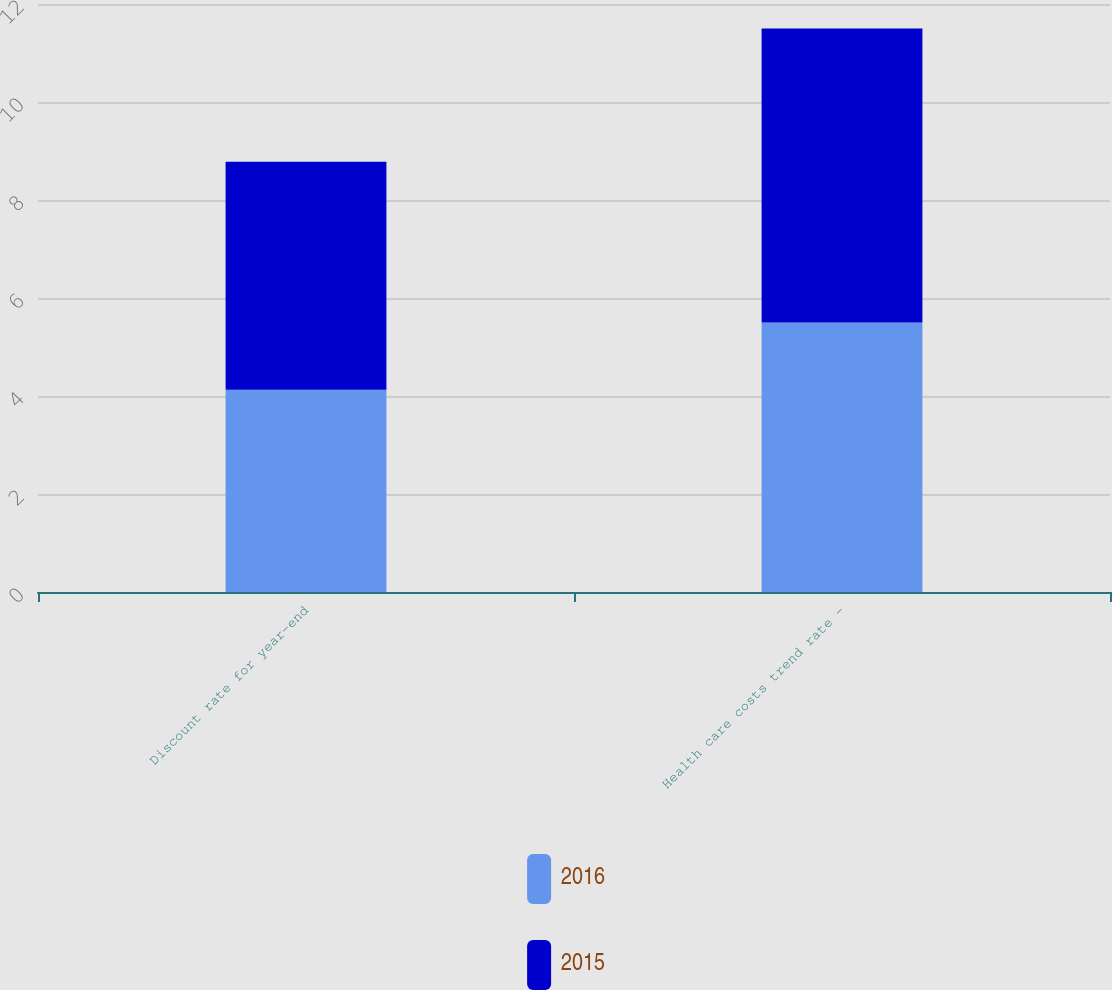Convert chart to OTSL. <chart><loc_0><loc_0><loc_500><loc_500><stacked_bar_chart><ecel><fcel>Discount rate for year-end<fcel>Health care costs trend rate -<nl><fcel>2016<fcel>4.13<fcel>5.5<nl><fcel>2015<fcel>4.65<fcel>6<nl></chart> 